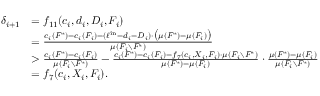Convert formula to latex. <formula><loc_0><loc_0><loc_500><loc_500>\begin{array} { r l } { \delta _ { i + 1 } } & { = f _ { 1 1 } ( c _ { i } , d _ { i } , D _ { i } , F _ { i } ) } & { = \frac { c _ { i } ( F ^ { * } ) - c _ { i } ( F _ { i } ) - ( \ell ^ { i n } - d _ { i } - D _ { i } ) \cdot \left ( \mu ( F ^ { * } ) - \mu ( F _ { i } ) \right ) } { \mu ( F _ { i } \ F ^ { * } ) } } & { > \frac { c _ { i } ( F ^ { * } ) - c _ { i } ( F _ { i } ) } { \mu ( F _ { i } \ F ^ { * } ) } - \frac { c _ { i } ( F ^ { * } ) - c _ { i } ( F _ { i } ) - f _ { 7 } ( c _ { i } , X _ { i } , F _ { i } ) \cdot \mu ( F _ { i } \ F ^ { * } ) } { \mu ( F ^ { * } ) - \mu ( F _ { i } ) } \cdot \frac { \mu ( F ^ { * } ) - \mu ( F _ { i } ) } { \mu ( F _ { i } \ F ^ { * } ) } } & { = f _ { 7 } ( c _ { i } , X _ { i } , F _ { i } ) . } \end{array}</formula> 